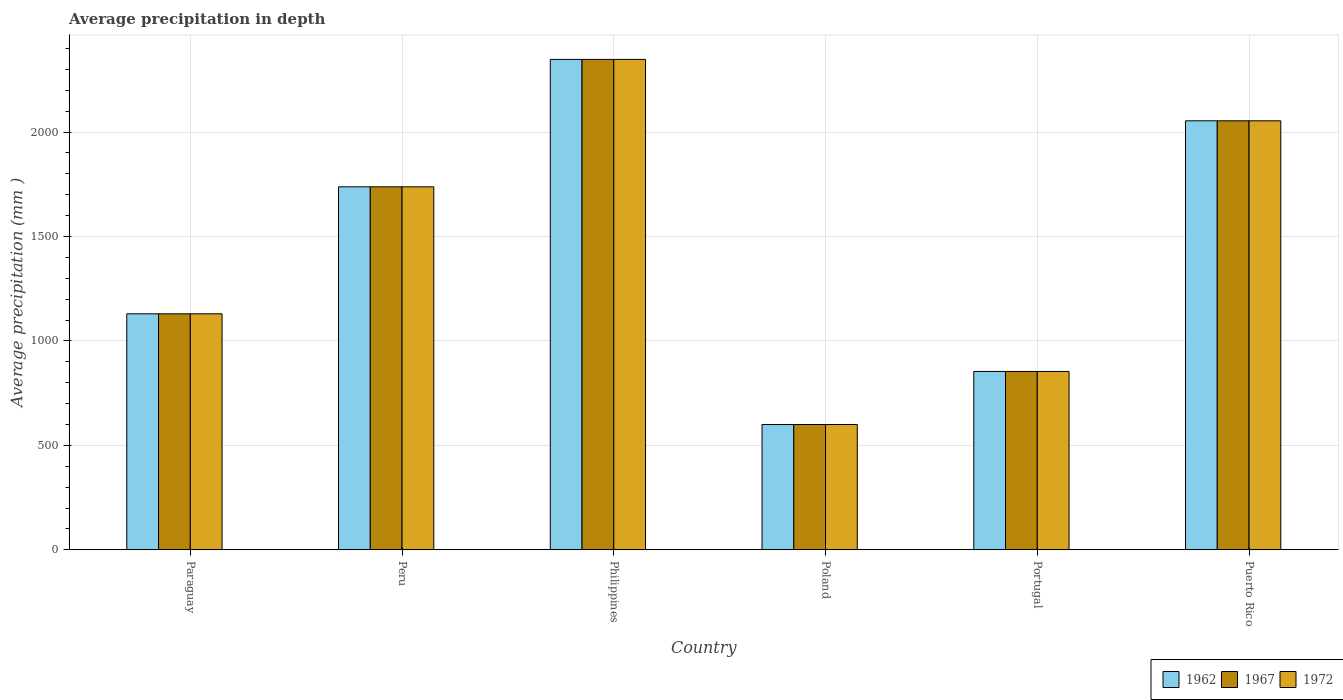How many different coloured bars are there?
Offer a very short reply. 3. Are the number of bars per tick equal to the number of legend labels?
Your response must be concise. Yes. Are the number of bars on each tick of the X-axis equal?
Provide a short and direct response. Yes. How many bars are there on the 3rd tick from the right?
Make the answer very short. 3. What is the label of the 2nd group of bars from the left?
Your answer should be very brief. Peru. What is the average precipitation in 1972 in Portugal?
Provide a succinct answer. 854. Across all countries, what is the maximum average precipitation in 1972?
Your answer should be compact. 2348. Across all countries, what is the minimum average precipitation in 1962?
Your answer should be very brief. 600. What is the total average precipitation in 1967 in the graph?
Ensure brevity in your answer.  8724. What is the difference between the average precipitation in 1962 in Philippines and that in Portugal?
Your answer should be compact. 1494. What is the difference between the average precipitation in 1972 in Philippines and the average precipitation in 1962 in Peru?
Give a very brief answer. 610. What is the average average precipitation in 1972 per country?
Your response must be concise. 1454. What is the difference between the average precipitation of/in 1967 and average precipitation of/in 1962 in Peru?
Your answer should be compact. 0. What is the ratio of the average precipitation in 1972 in Paraguay to that in Peru?
Your answer should be very brief. 0.65. What is the difference between the highest and the second highest average precipitation in 1967?
Your response must be concise. -610. What is the difference between the highest and the lowest average precipitation in 1962?
Your response must be concise. 1748. Is the sum of the average precipitation in 1962 in Paraguay and Puerto Rico greater than the maximum average precipitation in 1967 across all countries?
Your response must be concise. Yes. What does the 3rd bar from the left in Philippines represents?
Provide a succinct answer. 1972. What does the 2nd bar from the right in Paraguay represents?
Ensure brevity in your answer.  1967. How many bars are there?
Provide a succinct answer. 18. How many countries are there in the graph?
Provide a short and direct response. 6. Are the values on the major ticks of Y-axis written in scientific E-notation?
Offer a terse response. No. Does the graph contain any zero values?
Provide a short and direct response. No. Does the graph contain grids?
Offer a very short reply. Yes. Where does the legend appear in the graph?
Your answer should be very brief. Bottom right. How are the legend labels stacked?
Your answer should be very brief. Horizontal. What is the title of the graph?
Provide a succinct answer. Average precipitation in depth. What is the label or title of the Y-axis?
Keep it short and to the point. Average precipitation (mm ). What is the Average precipitation (mm ) of 1962 in Paraguay?
Provide a succinct answer. 1130. What is the Average precipitation (mm ) of 1967 in Paraguay?
Give a very brief answer. 1130. What is the Average precipitation (mm ) of 1972 in Paraguay?
Give a very brief answer. 1130. What is the Average precipitation (mm ) of 1962 in Peru?
Offer a terse response. 1738. What is the Average precipitation (mm ) of 1967 in Peru?
Provide a succinct answer. 1738. What is the Average precipitation (mm ) of 1972 in Peru?
Your answer should be compact. 1738. What is the Average precipitation (mm ) in 1962 in Philippines?
Offer a terse response. 2348. What is the Average precipitation (mm ) of 1967 in Philippines?
Your answer should be very brief. 2348. What is the Average precipitation (mm ) in 1972 in Philippines?
Your response must be concise. 2348. What is the Average precipitation (mm ) of 1962 in Poland?
Offer a very short reply. 600. What is the Average precipitation (mm ) in 1967 in Poland?
Offer a very short reply. 600. What is the Average precipitation (mm ) of 1972 in Poland?
Your answer should be very brief. 600. What is the Average precipitation (mm ) of 1962 in Portugal?
Give a very brief answer. 854. What is the Average precipitation (mm ) in 1967 in Portugal?
Provide a succinct answer. 854. What is the Average precipitation (mm ) of 1972 in Portugal?
Your answer should be very brief. 854. What is the Average precipitation (mm ) in 1962 in Puerto Rico?
Ensure brevity in your answer.  2054. What is the Average precipitation (mm ) of 1967 in Puerto Rico?
Offer a terse response. 2054. What is the Average precipitation (mm ) of 1972 in Puerto Rico?
Offer a very short reply. 2054. Across all countries, what is the maximum Average precipitation (mm ) in 1962?
Ensure brevity in your answer.  2348. Across all countries, what is the maximum Average precipitation (mm ) of 1967?
Give a very brief answer. 2348. Across all countries, what is the maximum Average precipitation (mm ) of 1972?
Give a very brief answer. 2348. Across all countries, what is the minimum Average precipitation (mm ) in 1962?
Your response must be concise. 600. Across all countries, what is the minimum Average precipitation (mm ) in 1967?
Make the answer very short. 600. Across all countries, what is the minimum Average precipitation (mm ) of 1972?
Make the answer very short. 600. What is the total Average precipitation (mm ) of 1962 in the graph?
Make the answer very short. 8724. What is the total Average precipitation (mm ) of 1967 in the graph?
Offer a very short reply. 8724. What is the total Average precipitation (mm ) in 1972 in the graph?
Make the answer very short. 8724. What is the difference between the Average precipitation (mm ) in 1962 in Paraguay and that in Peru?
Make the answer very short. -608. What is the difference between the Average precipitation (mm ) in 1967 in Paraguay and that in Peru?
Give a very brief answer. -608. What is the difference between the Average precipitation (mm ) of 1972 in Paraguay and that in Peru?
Provide a succinct answer. -608. What is the difference between the Average precipitation (mm ) of 1962 in Paraguay and that in Philippines?
Offer a terse response. -1218. What is the difference between the Average precipitation (mm ) of 1967 in Paraguay and that in Philippines?
Make the answer very short. -1218. What is the difference between the Average precipitation (mm ) in 1972 in Paraguay and that in Philippines?
Give a very brief answer. -1218. What is the difference between the Average precipitation (mm ) in 1962 in Paraguay and that in Poland?
Make the answer very short. 530. What is the difference between the Average precipitation (mm ) of 1967 in Paraguay and that in Poland?
Your answer should be compact. 530. What is the difference between the Average precipitation (mm ) in 1972 in Paraguay and that in Poland?
Your response must be concise. 530. What is the difference between the Average precipitation (mm ) of 1962 in Paraguay and that in Portugal?
Your answer should be compact. 276. What is the difference between the Average precipitation (mm ) in 1967 in Paraguay and that in Portugal?
Your answer should be very brief. 276. What is the difference between the Average precipitation (mm ) in 1972 in Paraguay and that in Portugal?
Your response must be concise. 276. What is the difference between the Average precipitation (mm ) in 1962 in Paraguay and that in Puerto Rico?
Your response must be concise. -924. What is the difference between the Average precipitation (mm ) of 1967 in Paraguay and that in Puerto Rico?
Provide a short and direct response. -924. What is the difference between the Average precipitation (mm ) of 1972 in Paraguay and that in Puerto Rico?
Your answer should be compact. -924. What is the difference between the Average precipitation (mm ) in 1962 in Peru and that in Philippines?
Ensure brevity in your answer.  -610. What is the difference between the Average precipitation (mm ) in 1967 in Peru and that in Philippines?
Your answer should be very brief. -610. What is the difference between the Average precipitation (mm ) in 1972 in Peru and that in Philippines?
Your answer should be very brief. -610. What is the difference between the Average precipitation (mm ) in 1962 in Peru and that in Poland?
Offer a terse response. 1138. What is the difference between the Average precipitation (mm ) in 1967 in Peru and that in Poland?
Provide a succinct answer. 1138. What is the difference between the Average precipitation (mm ) of 1972 in Peru and that in Poland?
Your answer should be very brief. 1138. What is the difference between the Average precipitation (mm ) of 1962 in Peru and that in Portugal?
Ensure brevity in your answer.  884. What is the difference between the Average precipitation (mm ) of 1967 in Peru and that in Portugal?
Your answer should be compact. 884. What is the difference between the Average precipitation (mm ) in 1972 in Peru and that in Portugal?
Give a very brief answer. 884. What is the difference between the Average precipitation (mm ) in 1962 in Peru and that in Puerto Rico?
Your response must be concise. -316. What is the difference between the Average precipitation (mm ) of 1967 in Peru and that in Puerto Rico?
Your response must be concise. -316. What is the difference between the Average precipitation (mm ) of 1972 in Peru and that in Puerto Rico?
Your response must be concise. -316. What is the difference between the Average precipitation (mm ) in 1962 in Philippines and that in Poland?
Offer a terse response. 1748. What is the difference between the Average precipitation (mm ) in 1967 in Philippines and that in Poland?
Your response must be concise. 1748. What is the difference between the Average precipitation (mm ) of 1972 in Philippines and that in Poland?
Provide a succinct answer. 1748. What is the difference between the Average precipitation (mm ) in 1962 in Philippines and that in Portugal?
Ensure brevity in your answer.  1494. What is the difference between the Average precipitation (mm ) of 1967 in Philippines and that in Portugal?
Offer a very short reply. 1494. What is the difference between the Average precipitation (mm ) in 1972 in Philippines and that in Portugal?
Keep it short and to the point. 1494. What is the difference between the Average precipitation (mm ) of 1962 in Philippines and that in Puerto Rico?
Offer a very short reply. 294. What is the difference between the Average precipitation (mm ) of 1967 in Philippines and that in Puerto Rico?
Ensure brevity in your answer.  294. What is the difference between the Average precipitation (mm ) in 1972 in Philippines and that in Puerto Rico?
Your response must be concise. 294. What is the difference between the Average precipitation (mm ) in 1962 in Poland and that in Portugal?
Provide a succinct answer. -254. What is the difference between the Average precipitation (mm ) of 1967 in Poland and that in Portugal?
Offer a very short reply. -254. What is the difference between the Average precipitation (mm ) of 1972 in Poland and that in Portugal?
Keep it short and to the point. -254. What is the difference between the Average precipitation (mm ) in 1962 in Poland and that in Puerto Rico?
Make the answer very short. -1454. What is the difference between the Average precipitation (mm ) of 1967 in Poland and that in Puerto Rico?
Offer a terse response. -1454. What is the difference between the Average precipitation (mm ) of 1972 in Poland and that in Puerto Rico?
Give a very brief answer. -1454. What is the difference between the Average precipitation (mm ) in 1962 in Portugal and that in Puerto Rico?
Your response must be concise. -1200. What is the difference between the Average precipitation (mm ) of 1967 in Portugal and that in Puerto Rico?
Ensure brevity in your answer.  -1200. What is the difference between the Average precipitation (mm ) of 1972 in Portugal and that in Puerto Rico?
Give a very brief answer. -1200. What is the difference between the Average precipitation (mm ) of 1962 in Paraguay and the Average precipitation (mm ) of 1967 in Peru?
Keep it short and to the point. -608. What is the difference between the Average precipitation (mm ) in 1962 in Paraguay and the Average precipitation (mm ) in 1972 in Peru?
Offer a terse response. -608. What is the difference between the Average precipitation (mm ) of 1967 in Paraguay and the Average precipitation (mm ) of 1972 in Peru?
Provide a short and direct response. -608. What is the difference between the Average precipitation (mm ) in 1962 in Paraguay and the Average precipitation (mm ) in 1967 in Philippines?
Your response must be concise. -1218. What is the difference between the Average precipitation (mm ) of 1962 in Paraguay and the Average precipitation (mm ) of 1972 in Philippines?
Ensure brevity in your answer.  -1218. What is the difference between the Average precipitation (mm ) of 1967 in Paraguay and the Average precipitation (mm ) of 1972 in Philippines?
Your response must be concise. -1218. What is the difference between the Average precipitation (mm ) in 1962 in Paraguay and the Average precipitation (mm ) in 1967 in Poland?
Ensure brevity in your answer.  530. What is the difference between the Average precipitation (mm ) of 1962 in Paraguay and the Average precipitation (mm ) of 1972 in Poland?
Offer a very short reply. 530. What is the difference between the Average precipitation (mm ) of 1967 in Paraguay and the Average precipitation (mm ) of 1972 in Poland?
Give a very brief answer. 530. What is the difference between the Average precipitation (mm ) in 1962 in Paraguay and the Average precipitation (mm ) in 1967 in Portugal?
Keep it short and to the point. 276. What is the difference between the Average precipitation (mm ) in 1962 in Paraguay and the Average precipitation (mm ) in 1972 in Portugal?
Your response must be concise. 276. What is the difference between the Average precipitation (mm ) in 1967 in Paraguay and the Average precipitation (mm ) in 1972 in Portugal?
Make the answer very short. 276. What is the difference between the Average precipitation (mm ) of 1962 in Paraguay and the Average precipitation (mm ) of 1967 in Puerto Rico?
Your response must be concise. -924. What is the difference between the Average precipitation (mm ) of 1962 in Paraguay and the Average precipitation (mm ) of 1972 in Puerto Rico?
Keep it short and to the point. -924. What is the difference between the Average precipitation (mm ) of 1967 in Paraguay and the Average precipitation (mm ) of 1972 in Puerto Rico?
Your answer should be very brief. -924. What is the difference between the Average precipitation (mm ) of 1962 in Peru and the Average precipitation (mm ) of 1967 in Philippines?
Your response must be concise. -610. What is the difference between the Average precipitation (mm ) of 1962 in Peru and the Average precipitation (mm ) of 1972 in Philippines?
Provide a succinct answer. -610. What is the difference between the Average precipitation (mm ) of 1967 in Peru and the Average precipitation (mm ) of 1972 in Philippines?
Provide a short and direct response. -610. What is the difference between the Average precipitation (mm ) in 1962 in Peru and the Average precipitation (mm ) in 1967 in Poland?
Offer a very short reply. 1138. What is the difference between the Average precipitation (mm ) of 1962 in Peru and the Average precipitation (mm ) of 1972 in Poland?
Offer a very short reply. 1138. What is the difference between the Average precipitation (mm ) of 1967 in Peru and the Average precipitation (mm ) of 1972 in Poland?
Offer a very short reply. 1138. What is the difference between the Average precipitation (mm ) in 1962 in Peru and the Average precipitation (mm ) in 1967 in Portugal?
Your answer should be very brief. 884. What is the difference between the Average precipitation (mm ) of 1962 in Peru and the Average precipitation (mm ) of 1972 in Portugal?
Your answer should be very brief. 884. What is the difference between the Average precipitation (mm ) in 1967 in Peru and the Average precipitation (mm ) in 1972 in Portugal?
Ensure brevity in your answer.  884. What is the difference between the Average precipitation (mm ) in 1962 in Peru and the Average precipitation (mm ) in 1967 in Puerto Rico?
Provide a succinct answer. -316. What is the difference between the Average precipitation (mm ) in 1962 in Peru and the Average precipitation (mm ) in 1972 in Puerto Rico?
Give a very brief answer. -316. What is the difference between the Average precipitation (mm ) of 1967 in Peru and the Average precipitation (mm ) of 1972 in Puerto Rico?
Provide a succinct answer. -316. What is the difference between the Average precipitation (mm ) of 1962 in Philippines and the Average precipitation (mm ) of 1967 in Poland?
Provide a succinct answer. 1748. What is the difference between the Average precipitation (mm ) of 1962 in Philippines and the Average precipitation (mm ) of 1972 in Poland?
Provide a succinct answer. 1748. What is the difference between the Average precipitation (mm ) of 1967 in Philippines and the Average precipitation (mm ) of 1972 in Poland?
Keep it short and to the point. 1748. What is the difference between the Average precipitation (mm ) in 1962 in Philippines and the Average precipitation (mm ) in 1967 in Portugal?
Your response must be concise. 1494. What is the difference between the Average precipitation (mm ) in 1962 in Philippines and the Average precipitation (mm ) in 1972 in Portugal?
Your answer should be compact. 1494. What is the difference between the Average precipitation (mm ) of 1967 in Philippines and the Average precipitation (mm ) of 1972 in Portugal?
Ensure brevity in your answer.  1494. What is the difference between the Average precipitation (mm ) in 1962 in Philippines and the Average precipitation (mm ) in 1967 in Puerto Rico?
Give a very brief answer. 294. What is the difference between the Average precipitation (mm ) in 1962 in Philippines and the Average precipitation (mm ) in 1972 in Puerto Rico?
Your answer should be very brief. 294. What is the difference between the Average precipitation (mm ) of 1967 in Philippines and the Average precipitation (mm ) of 1972 in Puerto Rico?
Your answer should be very brief. 294. What is the difference between the Average precipitation (mm ) of 1962 in Poland and the Average precipitation (mm ) of 1967 in Portugal?
Make the answer very short. -254. What is the difference between the Average precipitation (mm ) of 1962 in Poland and the Average precipitation (mm ) of 1972 in Portugal?
Keep it short and to the point. -254. What is the difference between the Average precipitation (mm ) of 1967 in Poland and the Average precipitation (mm ) of 1972 in Portugal?
Provide a succinct answer. -254. What is the difference between the Average precipitation (mm ) of 1962 in Poland and the Average precipitation (mm ) of 1967 in Puerto Rico?
Offer a terse response. -1454. What is the difference between the Average precipitation (mm ) in 1962 in Poland and the Average precipitation (mm ) in 1972 in Puerto Rico?
Ensure brevity in your answer.  -1454. What is the difference between the Average precipitation (mm ) in 1967 in Poland and the Average precipitation (mm ) in 1972 in Puerto Rico?
Your response must be concise. -1454. What is the difference between the Average precipitation (mm ) in 1962 in Portugal and the Average precipitation (mm ) in 1967 in Puerto Rico?
Ensure brevity in your answer.  -1200. What is the difference between the Average precipitation (mm ) of 1962 in Portugal and the Average precipitation (mm ) of 1972 in Puerto Rico?
Keep it short and to the point. -1200. What is the difference between the Average precipitation (mm ) of 1967 in Portugal and the Average precipitation (mm ) of 1972 in Puerto Rico?
Keep it short and to the point. -1200. What is the average Average precipitation (mm ) of 1962 per country?
Provide a short and direct response. 1454. What is the average Average precipitation (mm ) of 1967 per country?
Give a very brief answer. 1454. What is the average Average precipitation (mm ) of 1972 per country?
Provide a short and direct response. 1454. What is the difference between the Average precipitation (mm ) of 1962 and Average precipitation (mm ) of 1972 in Paraguay?
Ensure brevity in your answer.  0. What is the difference between the Average precipitation (mm ) of 1962 and Average precipitation (mm ) of 1972 in Peru?
Your answer should be very brief. 0. What is the difference between the Average precipitation (mm ) of 1967 and Average precipitation (mm ) of 1972 in Peru?
Provide a short and direct response. 0. What is the difference between the Average precipitation (mm ) of 1962 and Average precipitation (mm ) of 1967 in Philippines?
Offer a very short reply. 0. What is the difference between the Average precipitation (mm ) in 1962 and Average precipitation (mm ) in 1972 in Philippines?
Offer a very short reply. 0. What is the difference between the Average precipitation (mm ) of 1967 and Average precipitation (mm ) of 1972 in Philippines?
Offer a very short reply. 0. What is the difference between the Average precipitation (mm ) in 1962 and Average precipitation (mm ) in 1967 in Poland?
Offer a terse response. 0. What is the ratio of the Average precipitation (mm ) of 1962 in Paraguay to that in Peru?
Your response must be concise. 0.65. What is the ratio of the Average precipitation (mm ) in 1967 in Paraguay to that in Peru?
Provide a short and direct response. 0.65. What is the ratio of the Average precipitation (mm ) in 1972 in Paraguay to that in Peru?
Ensure brevity in your answer.  0.65. What is the ratio of the Average precipitation (mm ) in 1962 in Paraguay to that in Philippines?
Ensure brevity in your answer.  0.48. What is the ratio of the Average precipitation (mm ) of 1967 in Paraguay to that in Philippines?
Provide a succinct answer. 0.48. What is the ratio of the Average precipitation (mm ) in 1972 in Paraguay to that in Philippines?
Keep it short and to the point. 0.48. What is the ratio of the Average precipitation (mm ) of 1962 in Paraguay to that in Poland?
Ensure brevity in your answer.  1.88. What is the ratio of the Average precipitation (mm ) of 1967 in Paraguay to that in Poland?
Ensure brevity in your answer.  1.88. What is the ratio of the Average precipitation (mm ) in 1972 in Paraguay to that in Poland?
Make the answer very short. 1.88. What is the ratio of the Average precipitation (mm ) of 1962 in Paraguay to that in Portugal?
Offer a terse response. 1.32. What is the ratio of the Average precipitation (mm ) of 1967 in Paraguay to that in Portugal?
Give a very brief answer. 1.32. What is the ratio of the Average precipitation (mm ) in 1972 in Paraguay to that in Portugal?
Your answer should be very brief. 1.32. What is the ratio of the Average precipitation (mm ) in 1962 in Paraguay to that in Puerto Rico?
Give a very brief answer. 0.55. What is the ratio of the Average precipitation (mm ) in 1967 in Paraguay to that in Puerto Rico?
Keep it short and to the point. 0.55. What is the ratio of the Average precipitation (mm ) of 1972 in Paraguay to that in Puerto Rico?
Provide a short and direct response. 0.55. What is the ratio of the Average precipitation (mm ) in 1962 in Peru to that in Philippines?
Offer a very short reply. 0.74. What is the ratio of the Average precipitation (mm ) of 1967 in Peru to that in Philippines?
Keep it short and to the point. 0.74. What is the ratio of the Average precipitation (mm ) of 1972 in Peru to that in Philippines?
Provide a succinct answer. 0.74. What is the ratio of the Average precipitation (mm ) of 1962 in Peru to that in Poland?
Offer a terse response. 2.9. What is the ratio of the Average precipitation (mm ) of 1967 in Peru to that in Poland?
Your response must be concise. 2.9. What is the ratio of the Average precipitation (mm ) of 1972 in Peru to that in Poland?
Offer a terse response. 2.9. What is the ratio of the Average precipitation (mm ) in 1962 in Peru to that in Portugal?
Your answer should be compact. 2.04. What is the ratio of the Average precipitation (mm ) of 1967 in Peru to that in Portugal?
Ensure brevity in your answer.  2.04. What is the ratio of the Average precipitation (mm ) in 1972 in Peru to that in Portugal?
Your answer should be very brief. 2.04. What is the ratio of the Average precipitation (mm ) of 1962 in Peru to that in Puerto Rico?
Ensure brevity in your answer.  0.85. What is the ratio of the Average precipitation (mm ) of 1967 in Peru to that in Puerto Rico?
Your response must be concise. 0.85. What is the ratio of the Average precipitation (mm ) of 1972 in Peru to that in Puerto Rico?
Your answer should be very brief. 0.85. What is the ratio of the Average precipitation (mm ) of 1962 in Philippines to that in Poland?
Give a very brief answer. 3.91. What is the ratio of the Average precipitation (mm ) in 1967 in Philippines to that in Poland?
Your answer should be very brief. 3.91. What is the ratio of the Average precipitation (mm ) in 1972 in Philippines to that in Poland?
Offer a terse response. 3.91. What is the ratio of the Average precipitation (mm ) of 1962 in Philippines to that in Portugal?
Give a very brief answer. 2.75. What is the ratio of the Average precipitation (mm ) in 1967 in Philippines to that in Portugal?
Offer a terse response. 2.75. What is the ratio of the Average precipitation (mm ) of 1972 in Philippines to that in Portugal?
Ensure brevity in your answer.  2.75. What is the ratio of the Average precipitation (mm ) of 1962 in Philippines to that in Puerto Rico?
Offer a very short reply. 1.14. What is the ratio of the Average precipitation (mm ) of 1967 in Philippines to that in Puerto Rico?
Keep it short and to the point. 1.14. What is the ratio of the Average precipitation (mm ) in 1972 in Philippines to that in Puerto Rico?
Keep it short and to the point. 1.14. What is the ratio of the Average precipitation (mm ) of 1962 in Poland to that in Portugal?
Provide a short and direct response. 0.7. What is the ratio of the Average precipitation (mm ) of 1967 in Poland to that in Portugal?
Ensure brevity in your answer.  0.7. What is the ratio of the Average precipitation (mm ) of 1972 in Poland to that in Portugal?
Give a very brief answer. 0.7. What is the ratio of the Average precipitation (mm ) of 1962 in Poland to that in Puerto Rico?
Offer a very short reply. 0.29. What is the ratio of the Average precipitation (mm ) in 1967 in Poland to that in Puerto Rico?
Offer a very short reply. 0.29. What is the ratio of the Average precipitation (mm ) of 1972 in Poland to that in Puerto Rico?
Provide a succinct answer. 0.29. What is the ratio of the Average precipitation (mm ) in 1962 in Portugal to that in Puerto Rico?
Give a very brief answer. 0.42. What is the ratio of the Average precipitation (mm ) in 1967 in Portugal to that in Puerto Rico?
Give a very brief answer. 0.42. What is the ratio of the Average precipitation (mm ) in 1972 in Portugal to that in Puerto Rico?
Give a very brief answer. 0.42. What is the difference between the highest and the second highest Average precipitation (mm ) of 1962?
Your response must be concise. 294. What is the difference between the highest and the second highest Average precipitation (mm ) of 1967?
Your answer should be very brief. 294. What is the difference between the highest and the second highest Average precipitation (mm ) of 1972?
Provide a short and direct response. 294. What is the difference between the highest and the lowest Average precipitation (mm ) in 1962?
Your answer should be very brief. 1748. What is the difference between the highest and the lowest Average precipitation (mm ) of 1967?
Your response must be concise. 1748. What is the difference between the highest and the lowest Average precipitation (mm ) of 1972?
Keep it short and to the point. 1748. 